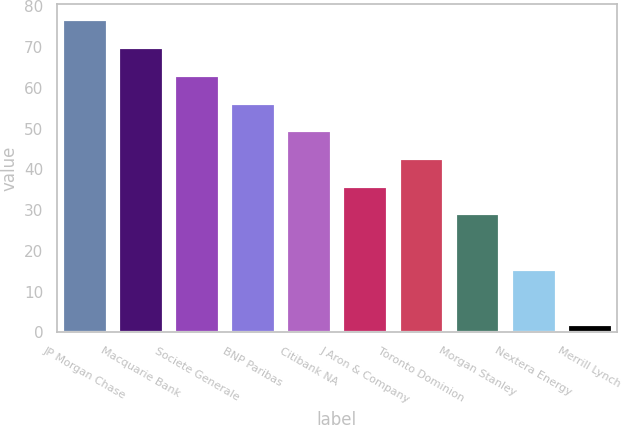Convert chart. <chart><loc_0><loc_0><loc_500><loc_500><bar_chart><fcel>JP Morgan Chase<fcel>Macquarie Bank<fcel>Societe Generale<fcel>BNP Paribas<fcel>Citibank NA<fcel>J Aron & Company<fcel>Toronto Dominion<fcel>Morgan Stanley<fcel>Nextera Energy<fcel>Merrill Lynch<nl><fcel>76.8<fcel>70<fcel>63.2<fcel>56.4<fcel>49.6<fcel>36<fcel>42.8<fcel>29.2<fcel>15.6<fcel>2<nl></chart> 